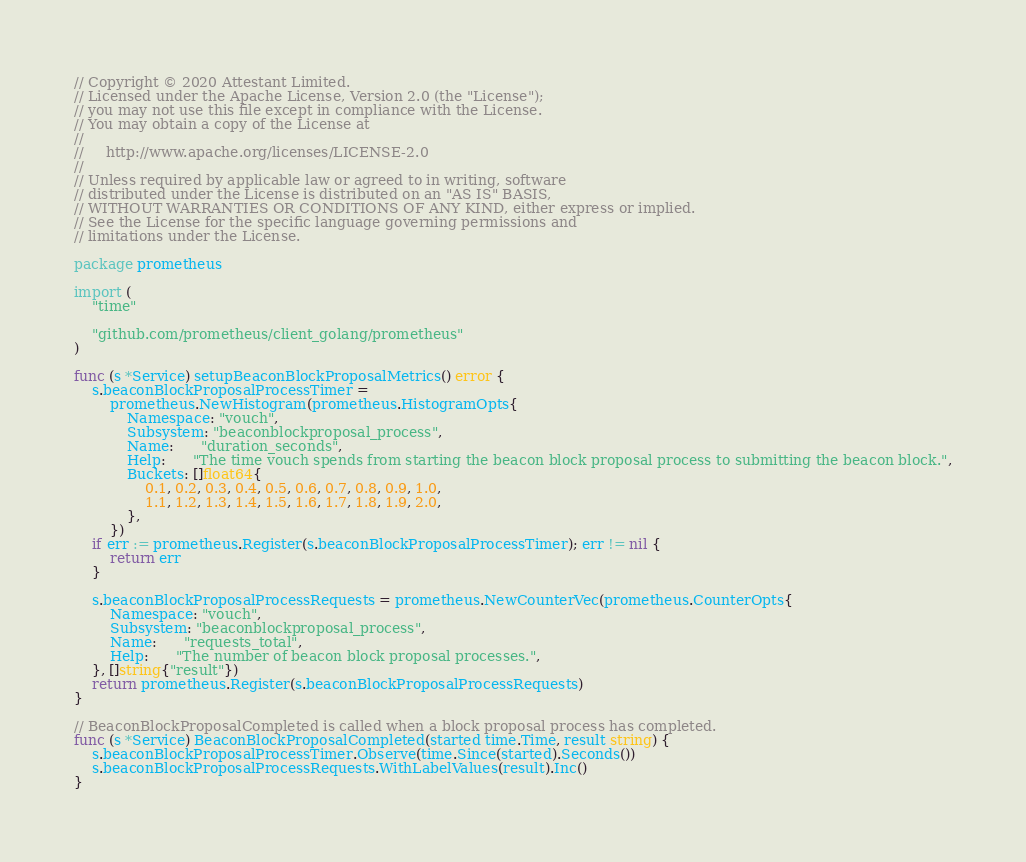<code> <loc_0><loc_0><loc_500><loc_500><_Go_>// Copyright © 2020 Attestant Limited.
// Licensed under the Apache License, Version 2.0 (the "License");
// you may not use this file except in compliance with the License.
// You may obtain a copy of the License at
//
//     http://www.apache.org/licenses/LICENSE-2.0
//
// Unless required by applicable law or agreed to in writing, software
// distributed under the License is distributed on an "AS IS" BASIS,
// WITHOUT WARRANTIES OR CONDITIONS OF ANY KIND, either express or implied.
// See the License for the specific language governing permissions and
// limitations under the License.

package prometheus

import (
	"time"

	"github.com/prometheus/client_golang/prometheus"
)

func (s *Service) setupBeaconBlockProposalMetrics() error {
	s.beaconBlockProposalProcessTimer =
		prometheus.NewHistogram(prometheus.HistogramOpts{
			Namespace: "vouch",
			Subsystem: "beaconblockproposal_process",
			Name:      "duration_seconds",
			Help:      "The time vouch spends from starting the beacon block proposal process to submitting the beacon block.",
			Buckets: []float64{
				0.1, 0.2, 0.3, 0.4, 0.5, 0.6, 0.7, 0.8, 0.9, 1.0,
				1.1, 1.2, 1.3, 1.4, 1.5, 1.6, 1.7, 1.8, 1.9, 2.0,
			},
		})
	if err := prometheus.Register(s.beaconBlockProposalProcessTimer); err != nil {
		return err
	}

	s.beaconBlockProposalProcessRequests = prometheus.NewCounterVec(prometheus.CounterOpts{
		Namespace: "vouch",
		Subsystem: "beaconblockproposal_process",
		Name:      "requests_total",
		Help:      "The number of beacon block proposal processes.",
	}, []string{"result"})
	return prometheus.Register(s.beaconBlockProposalProcessRequests)
}

// BeaconBlockProposalCompleted is called when a block proposal process has completed.
func (s *Service) BeaconBlockProposalCompleted(started time.Time, result string) {
	s.beaconBlockProposalProcessTimer.Observe(time.Since(started).Seconds())
	s.beaconBlockProposalProcessRequests.WithLabelValues(result).Inc()
}
</code> 